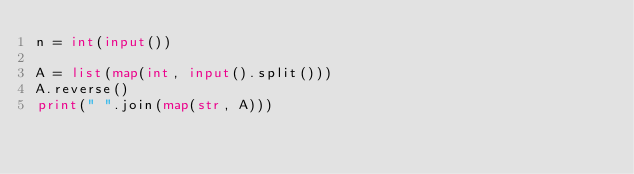<code> <loc_0><loc_0><loc_500><loc_500><_Python_>n = int(input())

A = list(map(int, input().split()))
A.reverse()
print(" ".join(map(str, A)))
</code> 